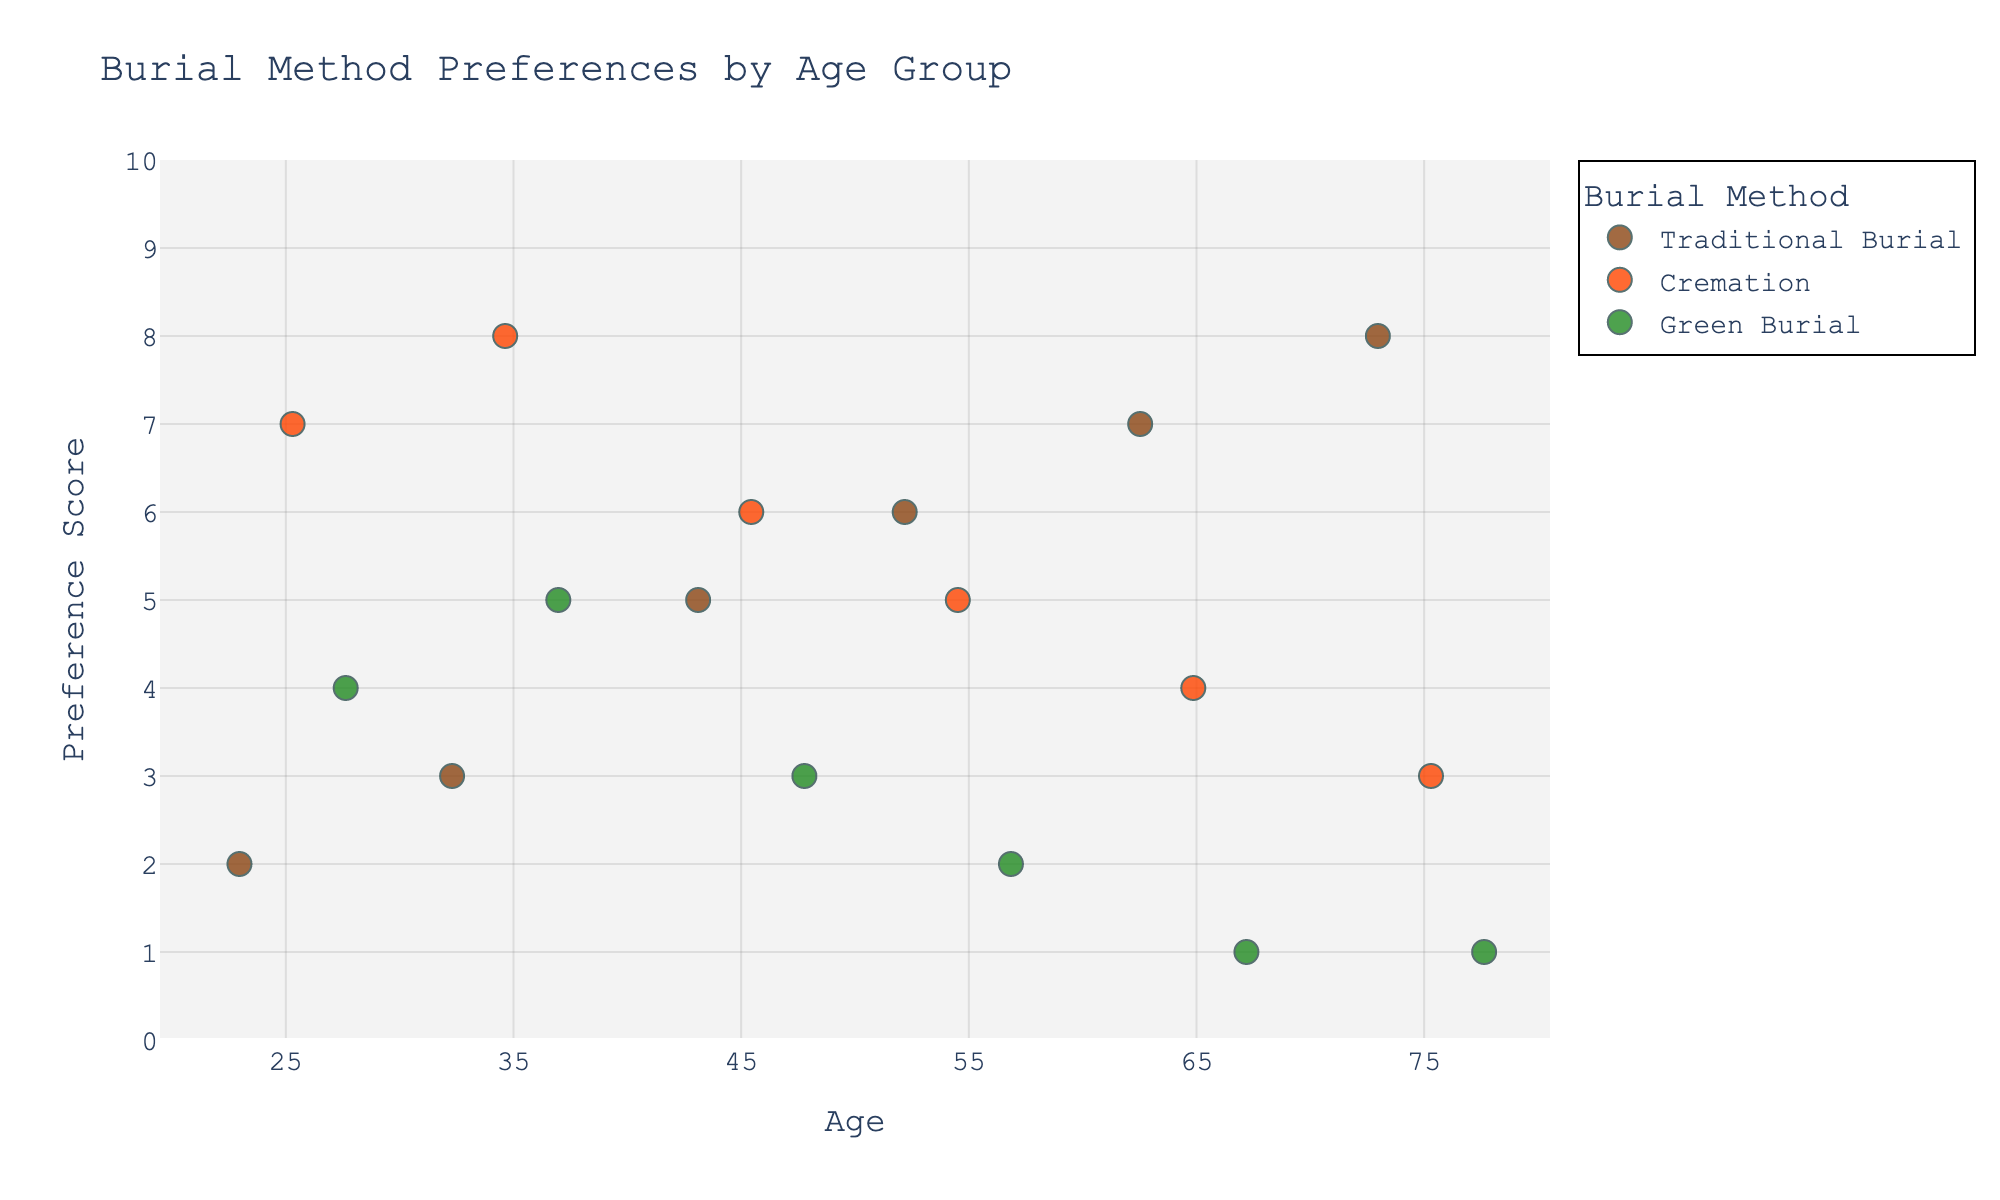What is the title of the figure? The title is usually displayed at the top of the figure. It provides a succinct summary of what the figure represents. Here, it indicates the subject of the plot—burial method preferences by age group.
Answer: Burial Method Preferences by Age Group Which burial method shows a decreasing trend in preference with increasing age? By observing the strip plot, note the positions of 'Preference' scores for each age group. Traditional Burial shows increasing preferences with age, while Cremation and Green Burial show a decreasing trend. Here, we focus on the burial method with a consistent decrease across all age groups.
Answer: Green Burial What is the preference score for Traditional Burial in the 45-year-old age group? Locate the 45-year-old group (X-axis) and the data points associated with Traditional Burial (color-coded). The 'Preference' score is marked on the Y-axis near this data point.
Answer: 5 How do the preference scores for Cremation differ between the 25-year-old and 55-year-old age groups? Compare the scores for Cremation in these two age groups: look at the 25-year-old group and note its preference score, then do the same for the 55-year-old group. Calculate the difference between them.
Answer: 2 Which age group shows the highest preference for Traditional Burial? Examine each age group (X-axis) and identify the preference scores for Traditional Burial (color-coded). The highest score indicates the age group with the maximum preference.
Answer: 75 Across all age groups, which burial method consistently shows the lowest preference score? Identify each burial method and note the minimum scores across all age groups. Compare to determine which method has the lowest consistent score.
Answer: Green Burial What is the average preference score for Green Burial across all age groups? Sum the preference scores for Green Burial across all age groups (4, 5, 3, 2, 1, 1) and divide by the number of age groups (6).
Answer: 2.67 Which age group has the most diverse preferences among the burial methods? For each age group, observe the spread of preference scores across the burial methods. Determine the group where the range (difference between highest and lowest score) is highest.
Answer: 45 What can be inferred about the trend in Traditional Burial preference with increasing age? Examine the figures for Traditional Burial across age groups. Notice the trend, whether the values increase, decrease, or remain constant as age progresses.
Answer: Increasing Compare the preference scores for the 35-year-old and the 65-year-old groups for Cremation. Which group shows a higher preference? Compare the preference scores associated with Cremation for the 35-year-old group and the 65-year-old group by identifying the color-coded points.
Answer: 35-year-old group 